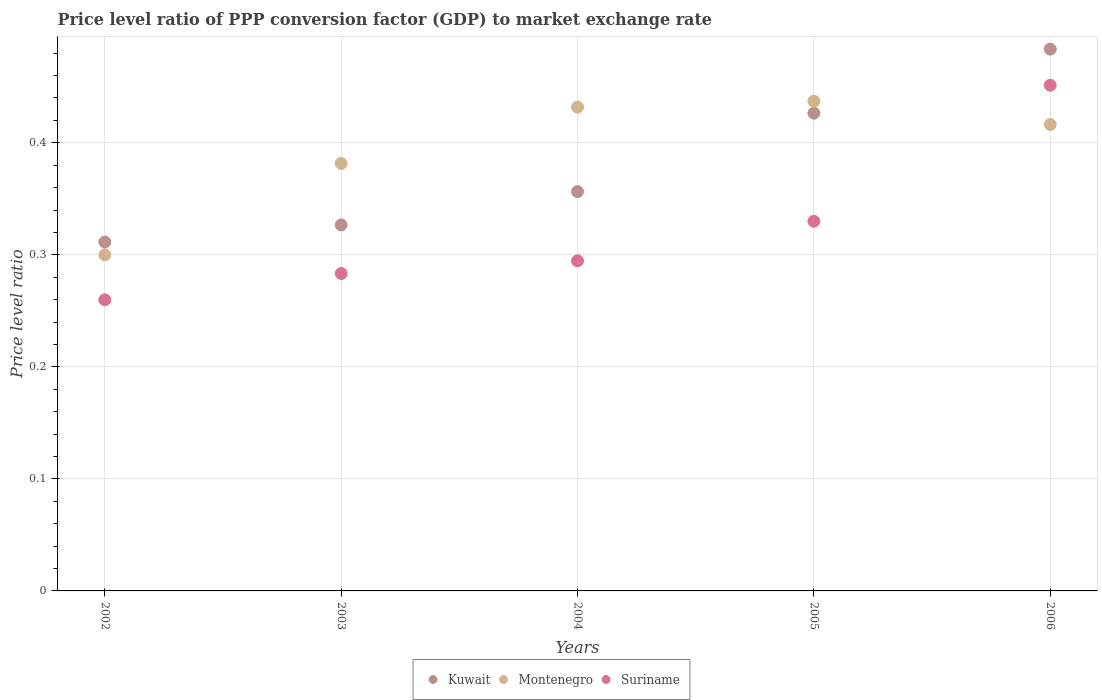How many different coloured dotlines are there?
Keep it short and to the point. 3. Is the number of dotlines equal to the number of legend labels?
Make the answer very short. Yes. What is the price level ratio in Suriname in 2003?
Give a very brief answer. 0.28. Across all years, what is the maximum price level ratio in Kuwait?
Keep it short and to the point. 0.48. Across all years, what is the minimum price level ratio in Suriname?
Ensure brevity in your answer.  0.26. In which year was the price level ratio in Montenegro minimum?
Keep it short and to the point. 2002. What is the total price level ratio in Montenegro in the graph?
Your response must be concise. 1.97. What is the difference between the price level ratio in Suriname in 2003 and that in 2005?
Provide a succinct answer. -0.05. What is the difference between the price level ratio in Kuwait in 2006 and the price level ratio in Montenegro in 2003?
Offer a terse response. 0.1. What is the average price level ratio in Kuwait per year?
Give a very brief answer. 0.38. In the year 2005, what is the difference between the price level ratio in Kuwait and price level ratio in Montenegro?
Your answer should be compact. -0.01. What is the ratio of the price level ratio in Suriname in 2003 to that in 2005?
Ensure brevity in your answer.  0.86. Is the difference between the price level ratio in Kuwait in 2002 and 2003 greater than the difference between the price level ratio in Montenegro in 2002 and 2003?
Offer a terse response. Yes. What is the difference between the highest and the second highest price level ratio in Kuwait?
Ensure brevity in your answer.  0.06. What is the difference between the highest and the lowest price level ratio in Montenegro?
Offer a terse response. 0.14. Is the sum of the price level ratio in Suriname in 2002 and 2003 greater than the maximum price level ratio in Montenegro across all years?
Provide a short and direct response. Yes. Is it the case that in every year, the sum of the price level ratio in Suriname and price level ratio in Kuwait  is greater than the price level ratio in Montenegro?
Keep it short and to the point. Yes. Does the price level ratio in Suriname monotonically increase over the years?
Your answer should be very brief. Yes. Is the price level ratio in Kuwait strictly greater than the price level ratio in Montenegro over the years?
Your answer should be very brief. No. Is the price level ratio in Suriname strictly less than the price level ratio in Montenegro over the years?
Your response must be concise. No. Are the values on the major ticks of Y-axis written in scientific E-notation?
Give a very brief answer. No. Does the graph contain any zero values?
Offer a terse response. No. Does the graph contain grids?
Make the answer very short. Yes. Where does the legend appear in the graph?
Keep it short and to the point. Bottom center. How are the legend labels stacked?
Give a very brief answer. Horizontal. What is the title of the graph?
Offer a terse response. Price level ratio of PPP conversion factor (GDP) to market exchange rate. Does "Honduras" appear as one of the legend labels in the graph?
Make the answer very short. No. What is the label or title of the Y-axis?
Keep it short and to the point. Price level ratio. What is the Price level ratio of Kuwait in 2002?
Provide a short and direct response. 0.31. What is the Price level ratio in Montenegro in 2002?
Give a very brief answer. 0.3. What is the Price level ratio of Suriname in 2002?
Offer a terse response. 0.26. What is the Price level ratio in Kuwait in 2003?
Offer a terse response. 0.33. What is the Price level ratio in Montenegro in 2003?
Provide a succinct answer. 0.38. What is the Price level ratio of Suriname in 2003?
Your response must be concise. 0.28. What is the Price level ratio in Kuwait in 2004?
Your answer should be compact. 0.36. What is the Price level ratio of Montenegro in 2004?
Provide a succinct answer. 0.43. What is the Price level ratio of Suriname in 2004?
Ensure brevity in your answer.  0.29. What is the Price level ratio in Kuwait in 2005?
Provide a short and direct response. 0.43. What is the Price level ratio in Montenegro in 2005?
Ensure brevity in your answer.  0.44. What is the Price level ratio in Suriname in 2005?
Offer a terse response. 0.33. What is the Price level ratio in Kuwait in 2006?
Provide a succinct answer. 0.48. What is the Price level ratio of Montenegro in 2006?
Your answer should be very brief. 0.42. What is the Price level ratio in Suriname in 2006?
Your answer should be compact. 0.45. Across all years, what is the maximum Price level ratio in Kuwait?
Keep it short and to the point. 0.48. Across all years, what is the maximum Price level ratio in Montenegro?
Give a very brief answer. 0.44. Across all years, what is the maximum Price level ratio of Suriname?
Your answer should be very brief. 0.45. Across all years, what is the minimum Price level ratio in Kuwait?
Provide a succinct answer. 0.31. Across all years, what is the minimum Price level ratio of Montenegro?
Your response must be concise. 0.3. Across all years, what is the minimum Price level ratio in Suriname?
Make the answer very short. 0.26. What is the total Price level ratio of Kuwait in the graph?
Provide a succinct answer. 1.9. What is the total Price level ratio of Montenegro in the graph?
Give a very brief answer. 1.97. What is the total Price level ratio in Suriname in the graph?
Offer a terse response. 1.62. What is the difference between the Price level ratio of Kuwait in 2002 and that in 2003?
Offer a very short reply. -0.02. What is the difference between the Price level ratio of Montenegro in 2002 and that in 2003?
Provide a short and direct response. -0.08. What is the difference between the Price level ratio of Suriname in 2002 and that in 2003?
Your response must be concise. -0.02. What is the difference between the Price level ratio in Kuwait in 2002 and that in 2004?
Provide a succinct answer. -0.04. What is the difference between the Price level ratio of Montenegro in 2002 and that in 2004?
Make the answer very short. -0.13. What is the difference between the Price level ratio of Suriname in 2002 and that in 2004?
Provide a succinct answer. -0.03. What is the difference between the Price level ratio of Kuwait in 2002 and that in 2005?
Your answer should be compact. -0.12. What is the difference between the Price level ratio in Montenegro in 2002 and that in 2005?
Keep it short and to the point. -0.14. What is the difference between the Price level ratio in Suriname in 2002 and that in 2005?
Make the answer very short. -0.07. What is the difference between the Price level ratio of Kuwait in 2002 and that in 2006?
Your response must be concise. -0.17. What is the difference between the Price level ratio of Montenegro in 2002 and that in 2006?
Ensure brevity in your answer.  -0.12. What is the difference between the Price level ratio of Suriname in 2002 and that in 2006?
Provide a succinct answer. -0.19. What is the difference between the Price level ratio of Kuwait in 2003 and that in 2004?
Make the answer very short. -0.03. What is the difference between the Price level ratio in Montenegro in 2003 and that in 2004?
Your response must be concise. -0.05. What is the difference between the Price level ratio in Suriname in 2003 and that in 2004?
Provide a short and direct response. -0.01. What is the difference between the Price level ratio of Kuwait in 2003 and that in 2005?
Your response must be concise. -0.1. What is the difference between the Price level ratio in Montenegro in 2003 and that in 2005?
Provide a short and direct response. -0.06. What is the difference between the Price level ratio of Suriname in 2003 and that in 2005?
Your response must be concise. -0.05. What is the difference between the Price level ratio in Kuwait in 2003 and that in 2006?
Make the answer very short. -0.16. What is the difference between the Price level ratio in Montenegro in 2003 and that in 2006?
Ensure brevity in your answer.  -0.03. What is the difference between the Price level ratio in Suriname in 2003 and that in 2006?
Provide a short and direct response. -0.17. What is the difference between the Price level ratio in Kuwait in 2004 and that in 2005?
Keep it short and to the point. -0.07. What is the difference between the Price level ratio of Montenegro in 2004 and that in 2005?
Your answer should be compact. -0.01. What is the difference between the Price level ratio in Suriname in 2004 and that in 2005?
Ensure brevity in your answer.  -0.04. What is the difference between the Price level ratio in Kuwait in 2004 and that in 2006?
Provide a short and direct response. -0.13. What is the difference between the Price level ratio of Montenegro in 2004 and that in 2006?
Offer a terse response. 0.02. What is the difference between the Price level ratio of Suriname in 2004 and that in 2006?
Provide a succinct answer. -0.16. What is the difference between the Price level ratio of Kuwait in 2005 and that in 2006?
Provide a succinct answer. -0.06. What is the difference between the Price level ratio in Montenegro in 2005 and that in 2006?
Offer a very short reply. 0.02. What is the difference between the Price level ratio of Suriname in 2005 and that in 2006?
Ensure brevity in your answer.  -0.12. What is the difference between the Price level ratio in Kuwait in 2002 and the Price level ratio in Montenegro in 2003?
Your answer should be compact. -0.07. What is the difference between the Price level ratio of Kuwait in 2002 and the Price level ratio of Suriname in 2003?
Provide a short and direct response. 0.03. What is the difference between the Price level ratio of Montenegro in 2002 and the Price level ratio of Suriname in 2003?
Make the answer very short. 0.02. What is the difference between the Price level ratio in Kuwait in 2002 and the Price level ratio in Montenegro in 2004?
Give a very brief answer. -0.12. What is the difference between the Price level ratio of Kuwait in 2002 and the Price level ratio of Suriname in 2004?
Your answer should be very brief. 0.02. What is the difference between the Price level ratio of Montenegro in 2002 and the Price level ratio of Suriname in 2004?
Make the answer very short. 0.01. What is the difference between the Price level ratio in Kuwait in 2002 and the Price level ratio in Montenegro in 2005?
Give a very brief answer. -0.13. What is the difference between the Price level ratio of Kuwait in 2002 and the Price level ratio of Suriname in 2005?
Offer a very short reply. -0.02. What is the difference between the Price level ratio in Montenegro in 2002 and the Price level ratio in Suriname in 2005?
Your answer should be very brief. -0.03. What is the difference between the Price level ratio in Kuwait in 2002 and the Price level ratio in Montenegro in 2006?
Your answer should be very brief. -0.1. What is the difference between the Price level ratio in Kuwait in 2002 and the Price level ratio in Suriname in 2006?
Make the answer very short. -0.14. What is the difference between the Price level ratio in Montenegro in 2002 and the Price level ratio in Suriname in 2006?
Your answer should be compact. -0.15. What is the difference between the Price level ratio of Kuwait in 2003 and the Price level ratio of Montenegro in 2004?
Keep it short and to the point. -0.11. What is the difference between the Price level ratio in Kuwait in 2003 and the Price level ratio in Suriname in 2004?
Ensure brevity in your answer.  0.03. What is the difference between the Price level ratio of Montenegro in 2003 and the Price level ratio of Suriname in 2004?
Your response must be concise. 0.09. What is the difference between the Price level ratio in Kuwait in 2003 and the Price level ratio in Montenegro in 2005?
Provide a succinct answer. -0.11. What is the difference between the Price level ratio in Kuwait in 2003 and the Price level ratio in Suriname in 2005?
Your answer should be compact. -0. What is the difference between the Price level ratio in Montenegro in 2003 and the Price level ratio in Suriname in 2005?
Make the answer very short. 0.05. What is the difference between the Price level ratio in Kuwait in 2003 and the Price level ratio in Montenegro in 2006?
Your response must be concise. -0.09. What is the difference between the Price level ratio of Kuwait in 2003 and the Price level ratio of Suriname in 2006?
Provide a short and direct response. -0.12. What is the difference between the Price level ratio of Montenegro in 2003 and the Price level ratio of Suriname in 2006?
Ensure brevity in your answer.  -0.07. What is the difference between the Price level ratio in Kuwait in 2004 and the Price level ratio in Montenegro in 2005?
Offer a terse response. -0.08. What is the difference between the Price level ratio in Kuwait in 2004 and the Price level ratio in Suriname in 2005?
Your response must be concise. 0.03. What is the difference between the Price level ratio in Montenegro in 2004 and the Price level ratio in Suriname in 2005?
Offer a terse response. 0.1. What is the difference between the Price level ratio of Kuwait in 2004 and the Price level ratio of Montenegro in 2006?
Your response must be concise. -0.06. What is the difference between the Price level ratio of Kuwait in 2004 and the Price level ratio of Suriname in 2006?
Your answer should be compact. -0.09. What is the difference between the Price level ratio in Montenegro in 2004 and the Price level ratio in Suriname in 2006?
Make the answer very short. -0.02. What is the difference between the Price level ratio in Kuwait in 2005 and the Price level ratio in Montenegro in 2006?
Your response must be concise. 0.01. What is the difference between the Price level ratio of Kuwait in 2005 and the Price level ratio of Suriname in 2006?
Offer a terse response. -0.02. What is the difference between the Price level ratio of Montenegro in 2005 and the Price level ratio of Suriname in 2006?
Give a very brief answer. -0.01. What is the average Price level ratio of Kuwait per year?
Your answer should be compact. 0.38. What is the average Price level ratio in Montenegro per year?
Provide a succinct answer. 0.39. What is the average Price level ratio of Suriname per year?
Keep it short and to the point. 0.32. In the year 2002, what is the difference between the Price level ratio of Kuwait and Price level ratio of Montenegro?
Ensure brevity in your answer.  0.01. In the year 2002, what is the difference between the Price level ratio of Kuwait and Price level ratio of Suriname?
Offer a terse response. 0.05. In the year 2002, what is the difference between the Price level ratio in Montenegro and Price level ratio in Suriname?
Offer a very short reply. 0.04. In the year 2003, what is the difference between the Price level ratio of Kuwait and Price level ratio of Montenegro?
Give a very brief answer. -0.05. In the year 2003, what is the difference between the Price level ratio in Kuwait and Price level ratio in Suriname?
Give a very brief answer. 0.04. In the year 2003, what is the difference between the Price level ratio of Montenegro and Price level ratio of Suriname?
Your answer should be compact. 0.1. In the year 2004, what is the difference between the Price level ratio of Kuwait and Price level ratio of Montenegro?
Your answer should be compact. -0.08. In the year 2004, what is the difference between the Price level ratio in Kuwait and Price level ratio in Suriname?
Keep it short and to the point. 0.06. In the year 2004, what is the difference between the Price level ratio of Montenegro and Price level ratio of Suriname?
Your answer should be very brief. 0.14. In the year 2005, what is the difference between the Price level ratio in Kuwait and Price level ratio in Montenegro?
Make the answer very short. -0.01. In the year 2005, what is the difference between the Price level ratio of Kuwait and Price level ratio of Suriname?
Provide a short and direct response. 0.1. In the year 2005, what is the difference between the Price level ratio of Montenegro and Price level ratio of Suriname?
Offer a very short reply. 0.11. In the year 2006, what is the difference between the Price level ratio in Kuwait and Price level ratio in Montenegro?
Your response must be concise. 0.07. In the year 2006, what is the difference between the Price level ratio in Kuwait and Price level ratio in Suriname?
Your answer should be very brief. 0.03. In the year 2006, what is the difference between the Price level ratio in Montenegro and Price level ratio in Suriname?
Your answer should be compact. -0.04. What is the ratio of the Price level ratio in Kuwait in 2002 to that in 2003?
Your answer should be very brief. 0.95. What is the ratio of the Price level ratio of Montenegro in 2002 to that in 2003?
Offer a very short reply. 0.79. What is the ratio of the Price level ratio in Suriname in 2002 to that in 2003?
Offer a very short reply. 0.92. What is the ratio of the Price level ratio of Kuwait in 2002 to that in 2004?
Provide a short and direct response. 0.87. What is the ratio of the Price level ratio of Montenegro in 2002 to that in 2004?
Offer a very short reply. 0.69. What is the ratio of the Price level ratio in Suriname in 2002 to that in 2004?
Ensure brevity in your answer.  0.88. What is the ratio of the Price level ratio in Kuwait in 2002 to that in 2005?
Offer a very short reply. 0.73. What is the ratio of the Price level ratio of Montenegro in 2002 to that in 2005?
Offer a terse response. 0.69. What is the ratio of the Price level ratio of Suriname in 2002 to that in 2005?
Keep it short and to the point. 0.79. What is the ratio of the Price level ratio of Kuwait in 2002 to that in 2006?
Keep it short and to the point. 0.64. What is the ratio of the Price level ratio in Montenegro in 2002 to that in 2006?
Your response must be concise. 0.72. What is the ratio of the Price level ratio of Suriname in 2002 to that in 2006?
Give a very brief answer. 0.58. What is the ratio of the Price level ratio of Montenegro in 2003 to that in 2004?
Offer a terse response. 0.88. What is the ratio of the Price level ratio in Suriname in 2003 to that in 2004?
Offer a very short reply. 0.96. What is the ratio of the Price level ratio of Kuwait in 2003 to that in 2005?
Your answer should be very brief. 0.77. What is the ratio of the Price level ratio of Montenegro in 2003 to that in 2005?
Provide a succinct answer. 0.87. What is the ratio of the Price level ratio of Suriname in 2003 to that in 2005?
Give a very brief answer. 0.86. What is the ratio of the Price level ratio in Kuwait in 2003 to that in 2006?
Give a very brief answer. 0.68. What is the ratio of the Price level ratio in Montenegro in 2003 to that in 2006?
Your answer should be very brief. 0.92. What is the ratio of the Price level ratio of Suriname in 2003 to that in 2006?
Provide a succinct answer. 0.63. What is the ratio of the Price level ratio of Kuwait in 2004 to that in 2005?
Offer a very short reply. 0.84. What is the ratio of the Price level ratio in Montenegro in 2004 to that in 2005?
Offer a terse response. 0.99. What is the ratio of the Price level ratio of Suriname in 2004 to that in 2005?
Your answer should be compact. 0.89. What is the ratio of the Price level ratio of Kuwait in 2004 to that in 2006?
Your answer should be very brief. 0.74. What is the ratio of the Price level ratio in Montenegro in 2004 to that in 2006?
Make the answer very short. 1.04. What is the ratio of the Price level ratio in Suriname in 2004 to that in 2006?
Make the answer very short. 0.65. What is the ratio of the Price level ratio in Kuwait in 2005 to that in 2006?
Your answer should be very brief. 0.88. What is the ratio of the Price level ratio in Suriname in 2005 to that in 2006?
Your response must be concise. 0.73. What is the difference between the highest and the second highest Price level ratio of Kuwait?
Make the answer very short. 0.06. What is the difference between the highest and the second highest Price level ratio of Montenegro?
Keep it short and to the point. 0.01. What is the difference between the highest and the second highest Price level ratio in Suriname?
Ensure brevity in your answer.  0.12. What is the difference between the highest and the lowest Price level ratio of Kuwait?
Ensure brevity in your answer.  0.17. What is the difference between the highest and the lowest Price level ratio of Montenegro?
Offer a very short reply. 0.14. What is the difference between the highest and the lowest Price level ratio of Suriname?
Your answer should be compact. 0.19. 